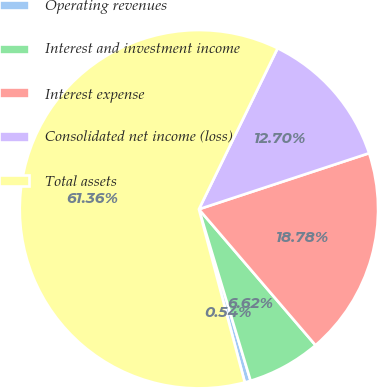Convert chart to OTSL. <chart><loc_0><loc_0><loc_500><loc_500><pie_chart><fcel>Operating revenues<fcel>Interest and investment income<fcel>Interest expense<fcel>Consolidated net income (loss)<fcel>Total assets<nl><fcel>0.54%<fcel>6.62%<fcel>18.78%<fcel>12.7%<fcel>61.35%<nl></chart> 